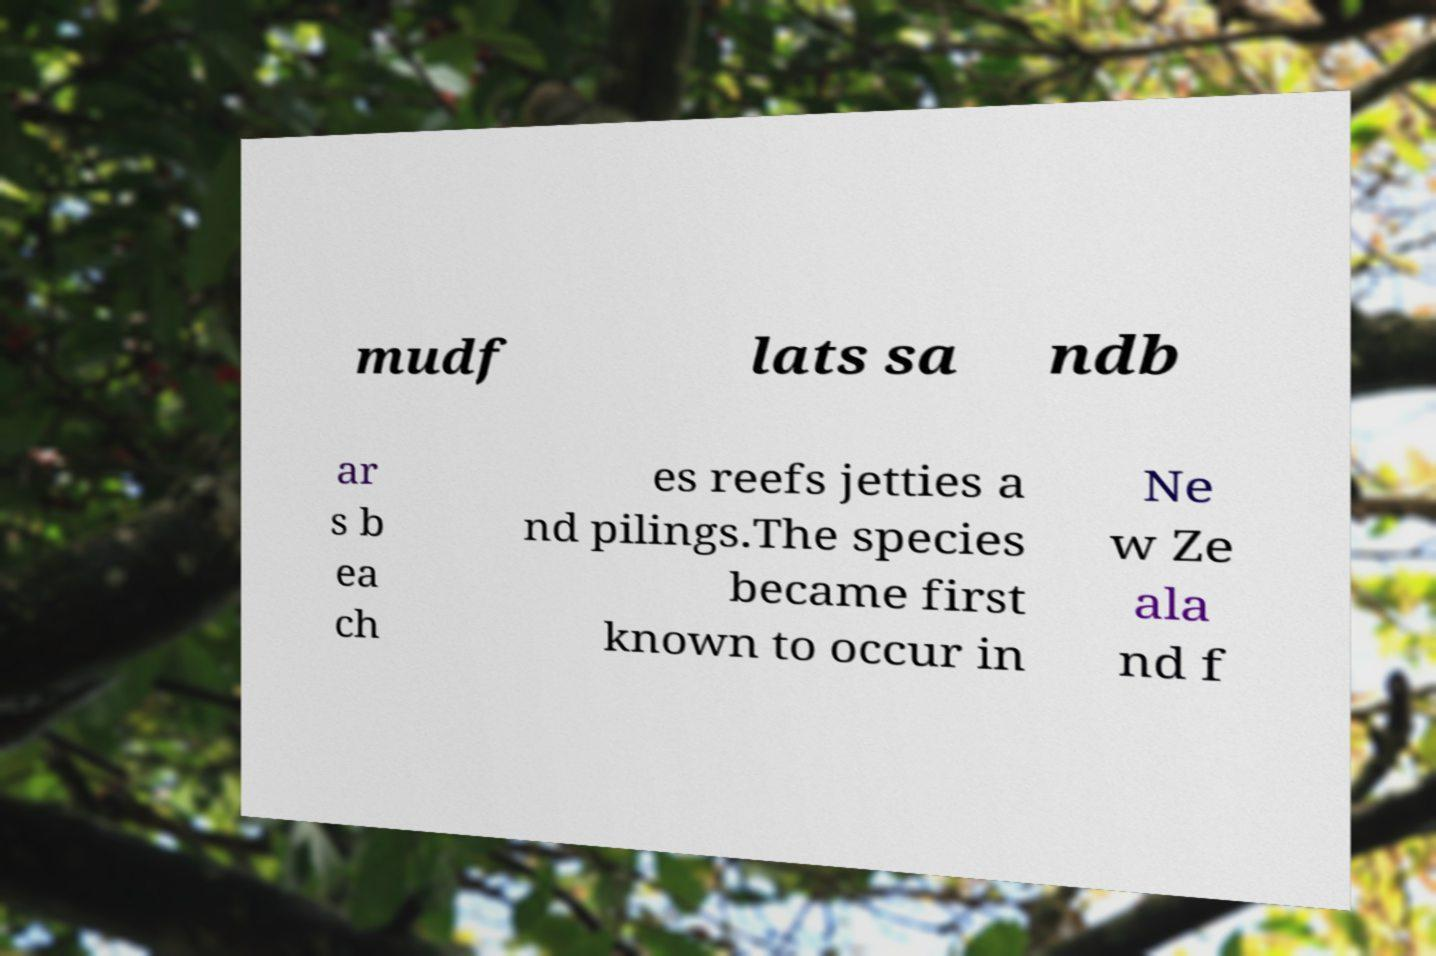Can you accurately transcribe the text from the provided image for me? mudf lats sa ndb ar s b ea ch es reefs jetties a nd pilings.The species became first known to occur in Ne w Ze ala nd f 